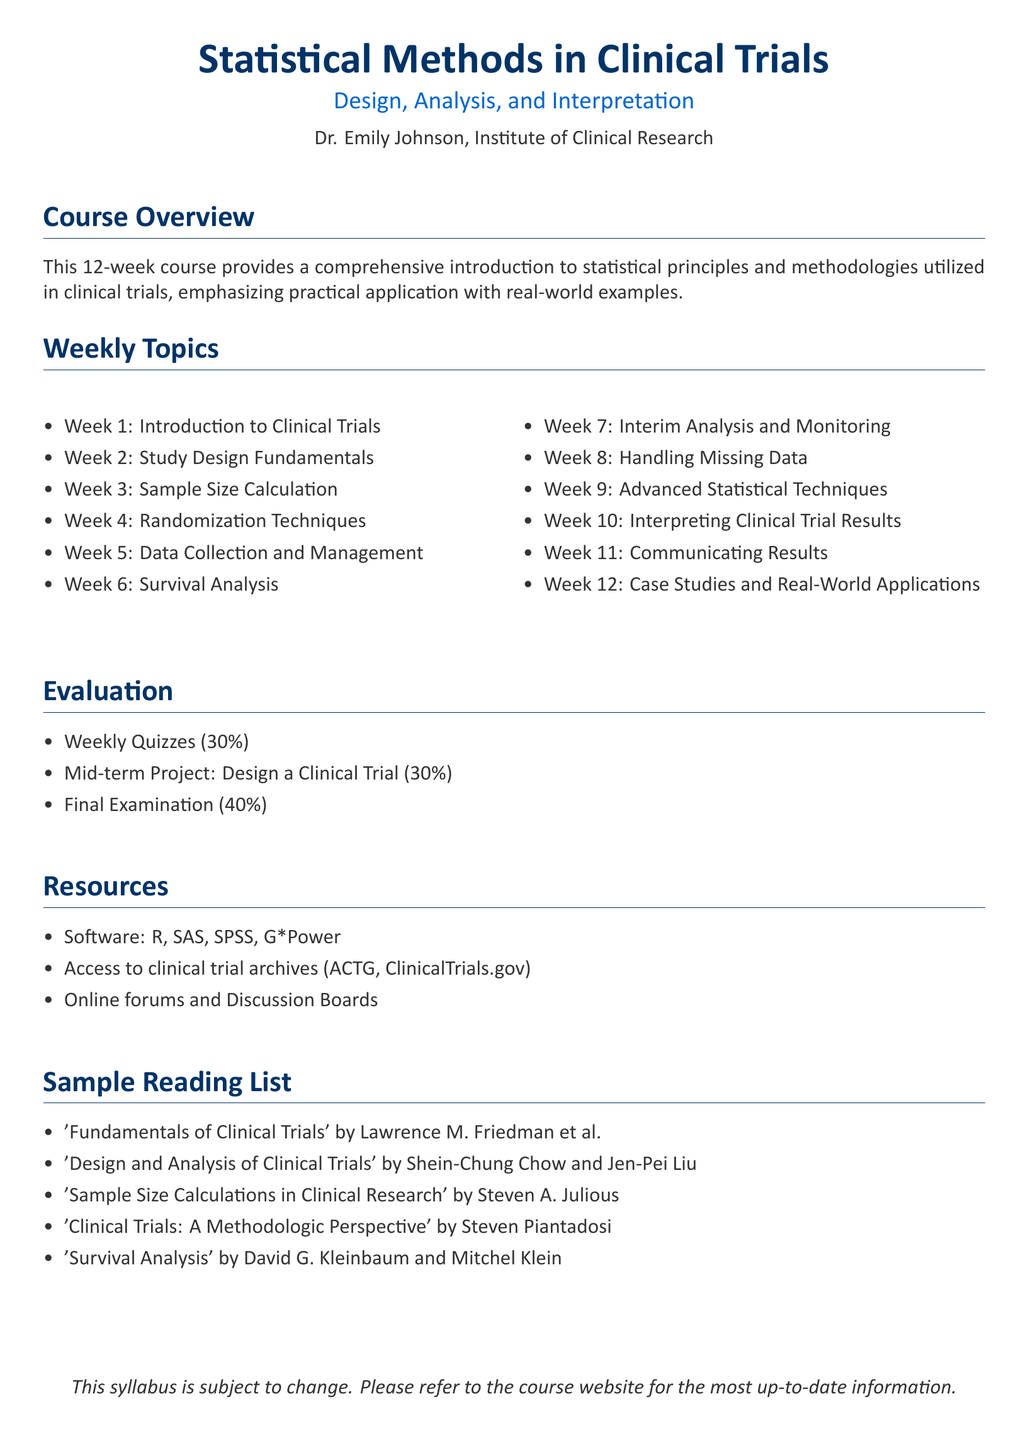What is the course duration? The course duration is specified in weeks, and it lasts for 12 weeks.
Answer: 12 weeks Who is the instructor of the course? The instructor's name is mentioned in the document as Dr. Emily Johnson.
Answer: Dr. Emily Johnson What percentage of the evaluation is the final examination? The evaluation section lists various components, with the final examination accounting for 40%.
Answer: 40% What is covered in week 6 of the course? The weekly topics section outlines that week 6 focuses on Survival Analysis.
Answer: Survival Analysis Which software is listed as a resource for the course? The resources section includes software referenced for statistical analysis, with R included among them.
Answer: R How many case studies are discussed in week 12? Week 12 is dedicated to case studies and real-world applications, but no specific number is stated.
Answer: Not specified What type of project is the mid-term? The mid-term project requires designing a clinical trial as articulated in the evaluation section.
Answer: Design a Clinical Trial What is the focus of week 10? Week 10's topic is listed as interpreting clinical trial results, indicating its focus area.
Answer: Interpreting Clinical Trial Results 